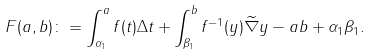Convert formula to latex. <formula><loc_0><loc_0><loc_500><loc_500>F ( a , b ) \colon = \int _ { \alpha _ { 1 } } ^ { a } f ( t ) \Delta t + \int _ { \beta _ { 1 } } ^ { b } f ^ { - 1 } ( y ) \widetilde { \nabla } y - a b + \alpha _ { 1 } \beta _ { 1 } .</formula> 